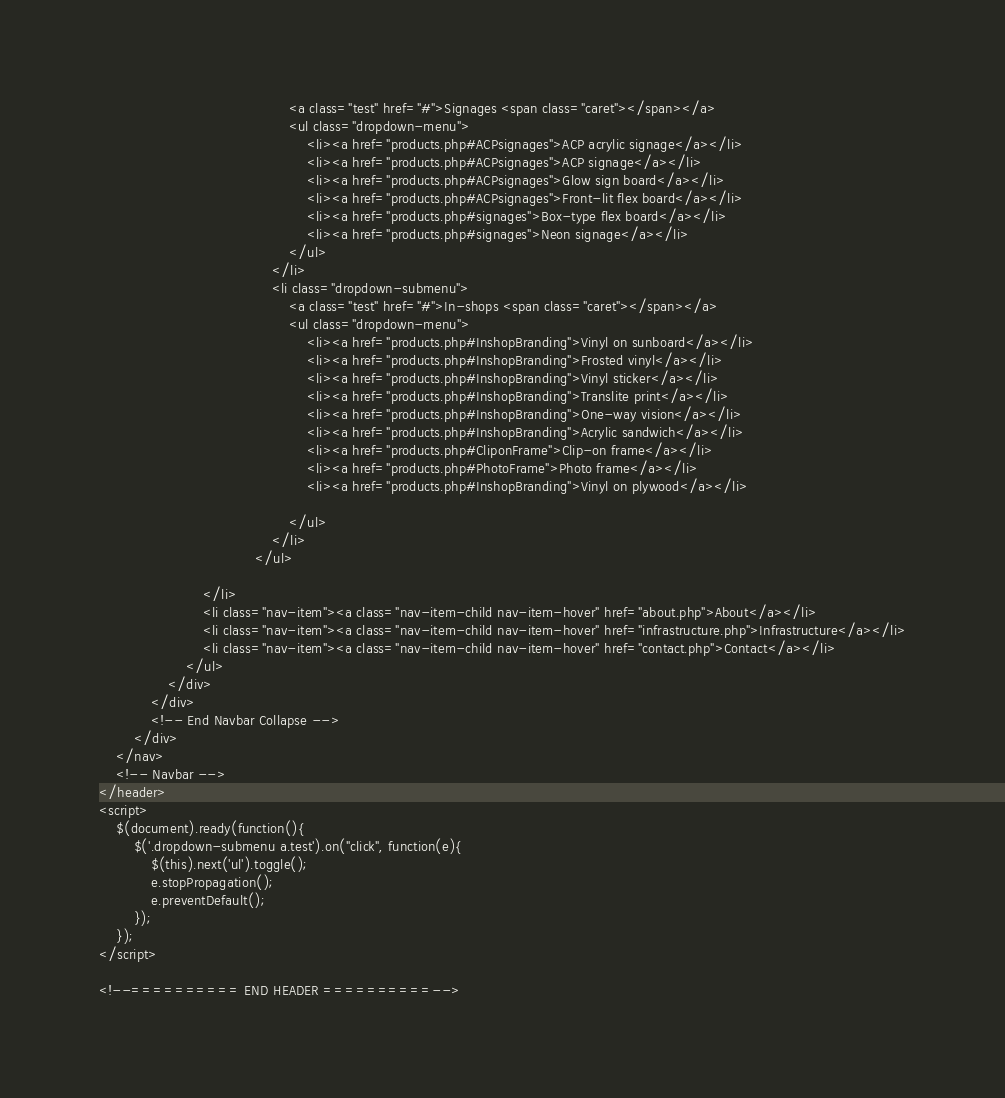Convert code to text. <code><loc_0><loc_0><loc_500><loc_500><_PHP_>                                            <a class="test" href="#">Signages <span class="caret"></span></a>
                                            <ul class="dropdown-menu">
                                                <li><a href="products.php#ACPsignages">ACP acrylic signage</a></li>
                                                <li><a href="products.php#ACPsignages">ACP signage</a></li>
                                                <li><a href="products.php#ACPsignages">Glow sign board</a></li>
                                                <li><a href="products.php#ACPsignages">Front-lit flex board</a></li>
                                                <li><a href="products.php#signages">Box-type flex board</a></li>
                                                <li><a href="products.php#signages">Neon signage</a></li>
                                            </ul>
                                        </li>
                                        <li class="dropdown-submenu">
                                            <a class="test" href="#">In-shops <span class="caret"></span></a>
                                            <ul class="dropdown-menu">
                                                <li><a href="products.php#InshopBranding">Vinyl on sunboard</a></li>
                                                <li><a href="products.php#InshopBranding">Frosted vinyl</a></li>
                                                <li><a href="products.php#InshopBranding">Vinyl sticker</a></li>
                                                <li><a href="products.php#InshopBranding">Translite print</a></li>
                                                <li><a href="products.php#InshopBranding">One-way vision</a></li>
                                                <li><a href="products.php#InshopBranding">Acrylic sandwich</a></li>
                                                <li><a href="products.php#CliponFrame">Clip-on frame</a></li>
                                                <li><a href="products.php#PhotoFrame">Photo frame</a></li>
                                                <li><a href="products.php#InshopBranding">Vinyl on plywood</a></li>

                                            </ul>
                                        </li>
                                    </ul>

                        </li>
                        <li class="nav-item"><a class="nav-item-child nav-item-hover" href="about.php">About</a></li>
                        <li class="nav-item"><a class="nav-item-child nav-item-hover" href="infrastructure.php">Infrastructure</a></li>
                        <li class="nav-item"><a class="nav-item-child nav-item-hover" href="contact.php">Contact</a></li>
                    </ul>
                </div>
            </div>
            <!-- End Navbar Collapse -->
        </div>
    </nav>
    <!-- Navbar -->
</header>
<script>
    $(document).ready(function(){
        $('.dropdown-submenu a.test').on("click", function(e){
            $(this).next('ul').toggle();
            e.stopPropagation();
            e.preventDefault();
        });
    });
</script>

<!--========== END HEADER ==========--></code> 